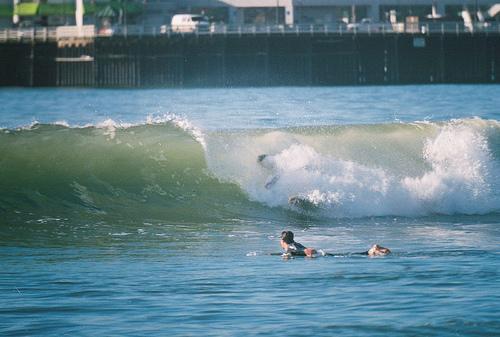How many people are in the water?
Give a very brief answer. 2. 